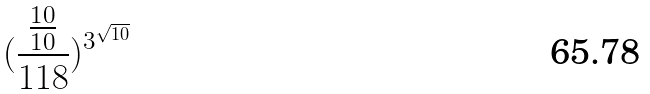<formula> <loc_0><loc_0><loc_500><loc_500>( \frac { \frac { 1 0 } { 1 0 } } { 1 1 8 } ) ^ { 3 ^ { \sqrt { 1 0 } } }</formula> 